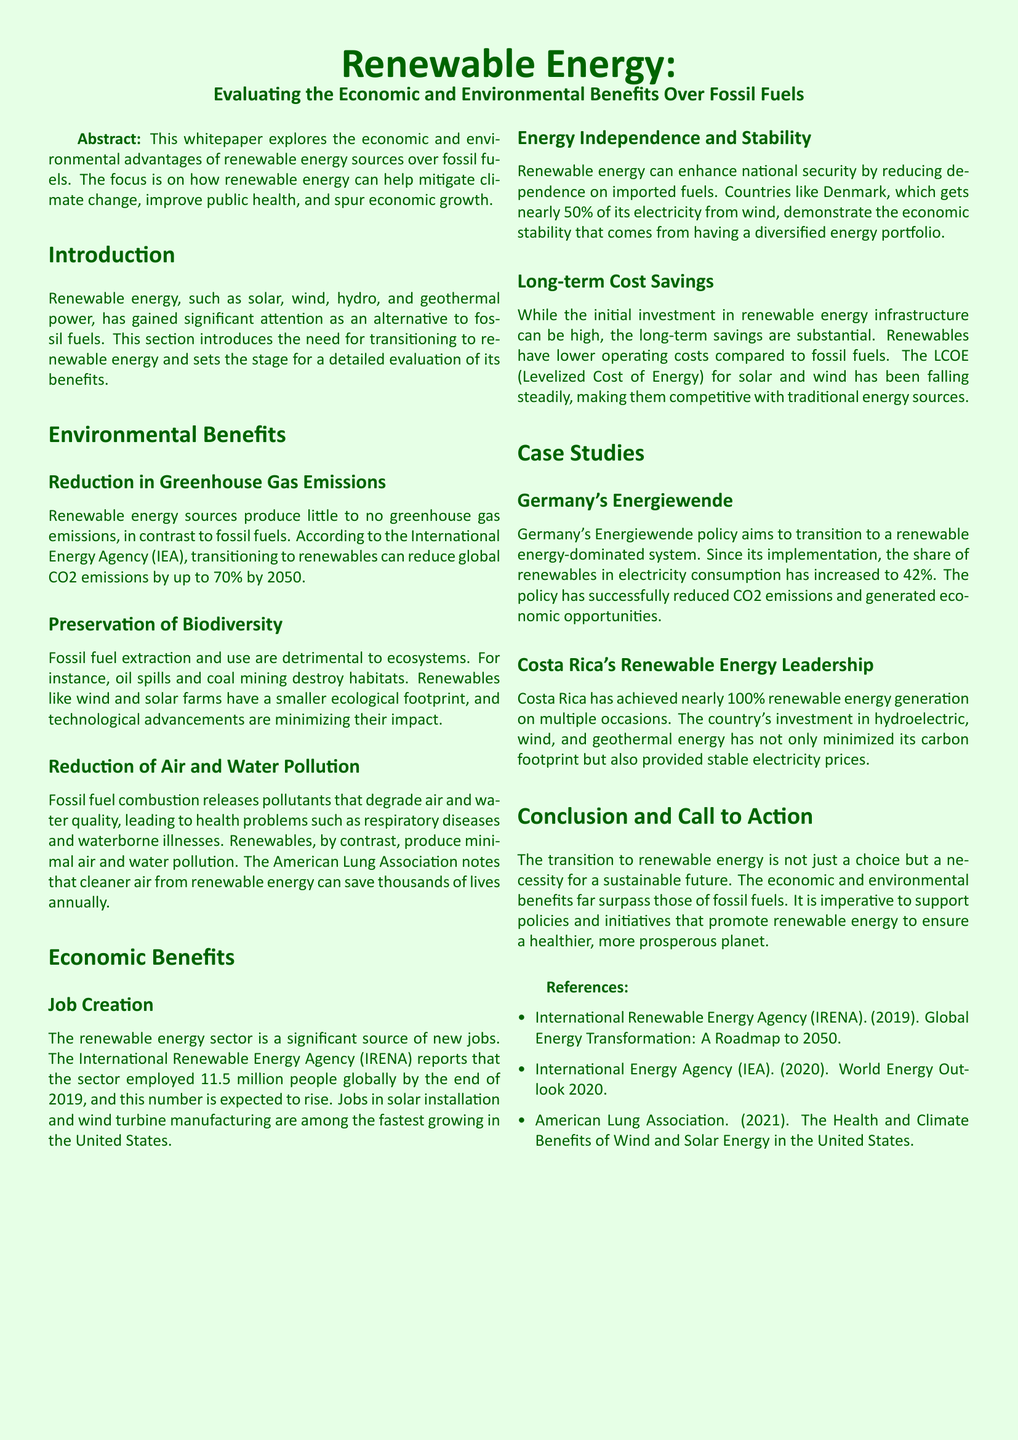What is the reduction potential of global CO2 emissions by 2050? The document states that transitioning to renewables can reduce global CO2 emissions by up to 70% by 2050.
Answer: 70% What is the significance of Germany's Energiewende policy? The policy aims to transition to a renewable energy-dominated system, successfully increasing renewables' share in electricity consumption to 42%.
Answer: 42% Which sector employed 11.5 million people globally by the end of 2019? The document indicates that the renewable energy sector employed 11.5 million people globally by the end of 2019.
Answer: Renewable energy sector How do renewable energy sources compare to fossil fuels in terms of air and water pollution? The document mentions that renewables produce minimal air and water pollution, unlike fossil fuels which release harmful pollutants.
Answer: Minimal What are the economic benefits of renewable energy mentioned in the document? The document lists job creation, energy independence, and long-term cost savings as economic benefits of renewable energy.
Answer: Job creation, energy independence, long-term cost savings What is Costa Rica's renewable energy generation achievement? The document states that Costa Rica has achieved nearly 100% renewable energy generation on multiple occasions.
Answer: Nearly 100% What has reduced through the cleaner air from renewable energy according to the American Lung Association? The document notes that cleaner air from renewable energy can save thousands of lives annually.
Answer: Thousands of lives What are the types of renewable energy highlighted in the document? The document highlights solar, wind, hydro, and geothermal power as types of renewable energy.
Answer: Solar, wind, hydro, geothermal How does the Levelized Cost of Energy (LCOE) for solar and wind compare to traditional energy sources? The document mentions that the LCOE for solar and wind has been falling steadily, making them competitive with traditional energy sources.
Answer: Competitive 